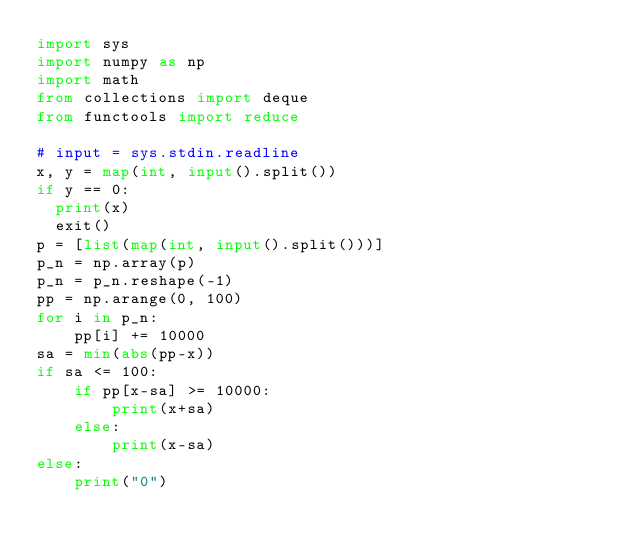Convert code to text. <code><loc_0><loc_0><loc_500><loc_500><_Python_>import sys
import numpy as np
import math
from collections import deque 
from functools import reduce

# input = sys.stdin.readline
x, y = map(int, input().split())
if y == 0:
  print(x)
  exit()
p = [list(map(int, input().split()))]
p_n = np.array(p)
p_n = p_n.reshape(-1)
pp = np.arange(0, 100)
for i in p_n:
    pp[i] += 10000
sa = min(abs(pp-x))
if sa <= 100:
    if pp[x-sa] >= 10000:
        print(x+sa)
    else:
        print(x-sa)
else:
    print("0")

</code> 